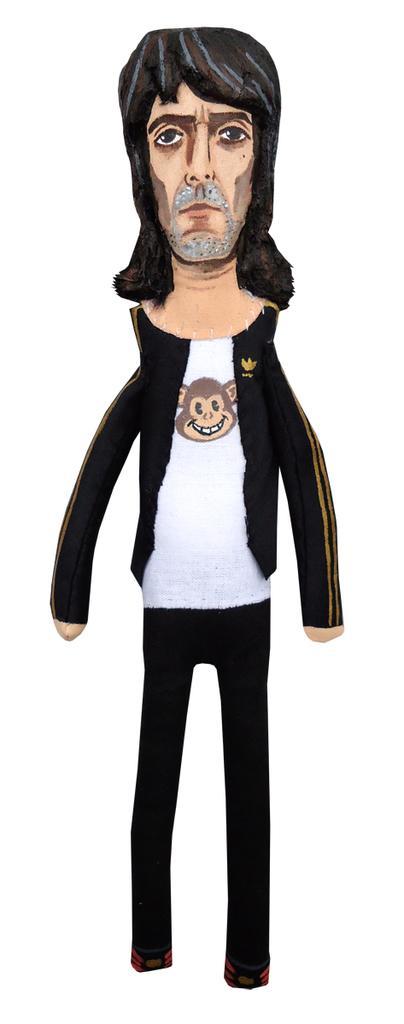In one or two sentences, can you explain what this image depicts? In this image I can see an animated image of a person. 